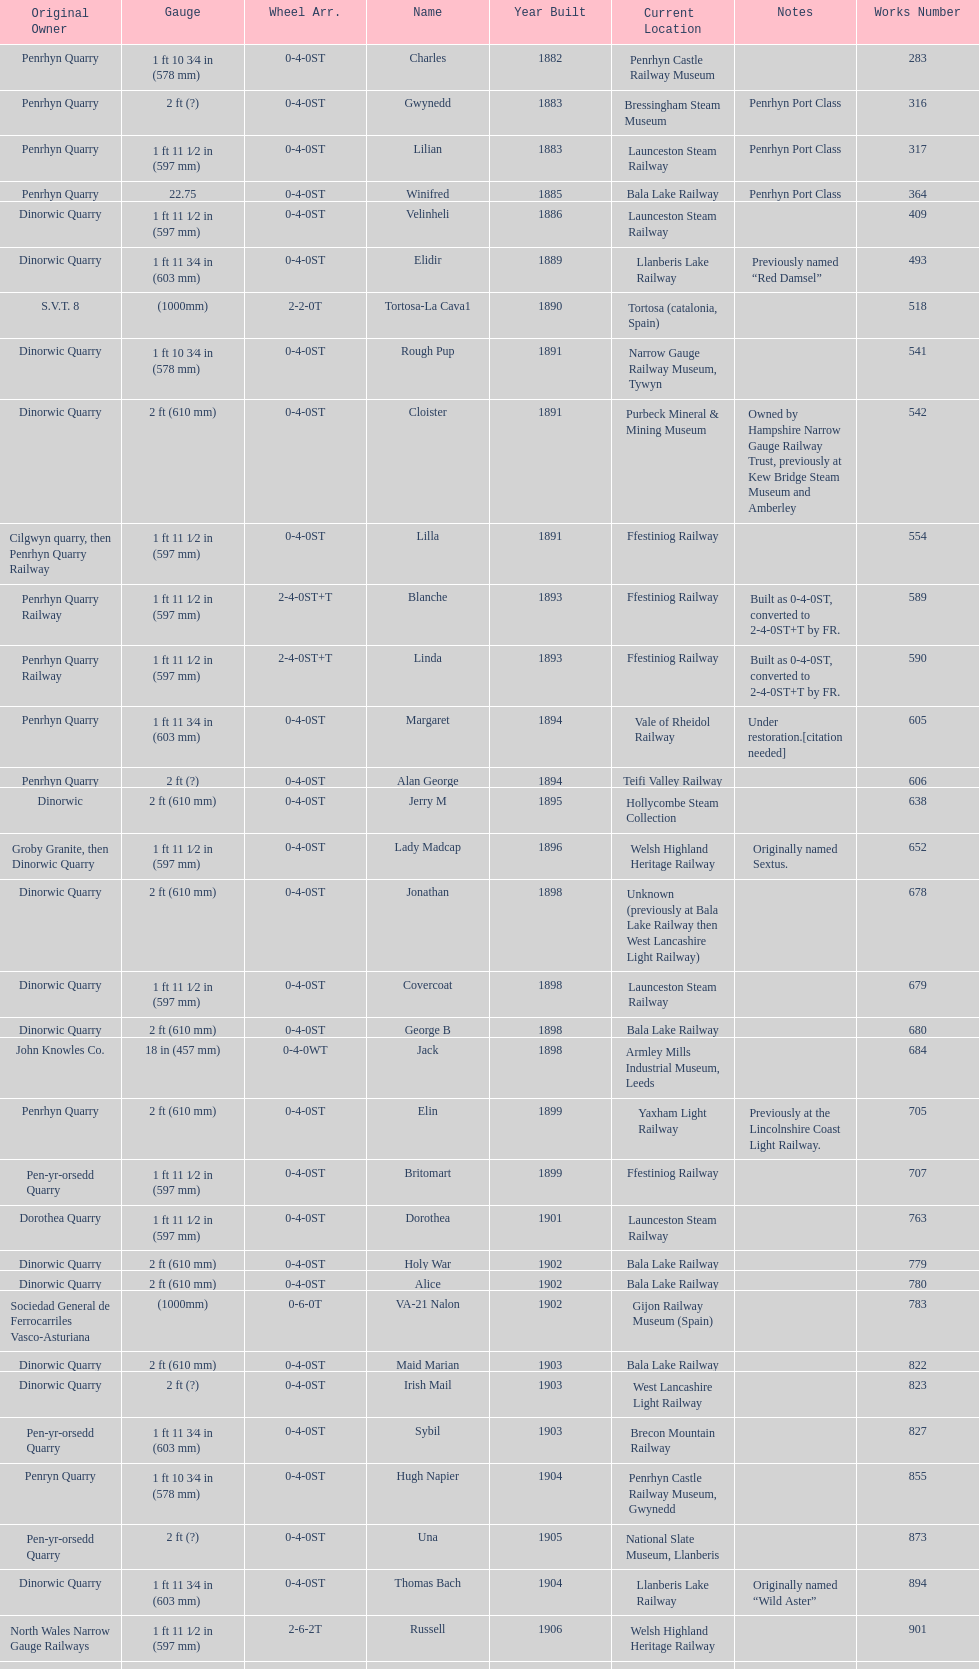Which original owner had the most locomotives? Penrhyn Quarry. 